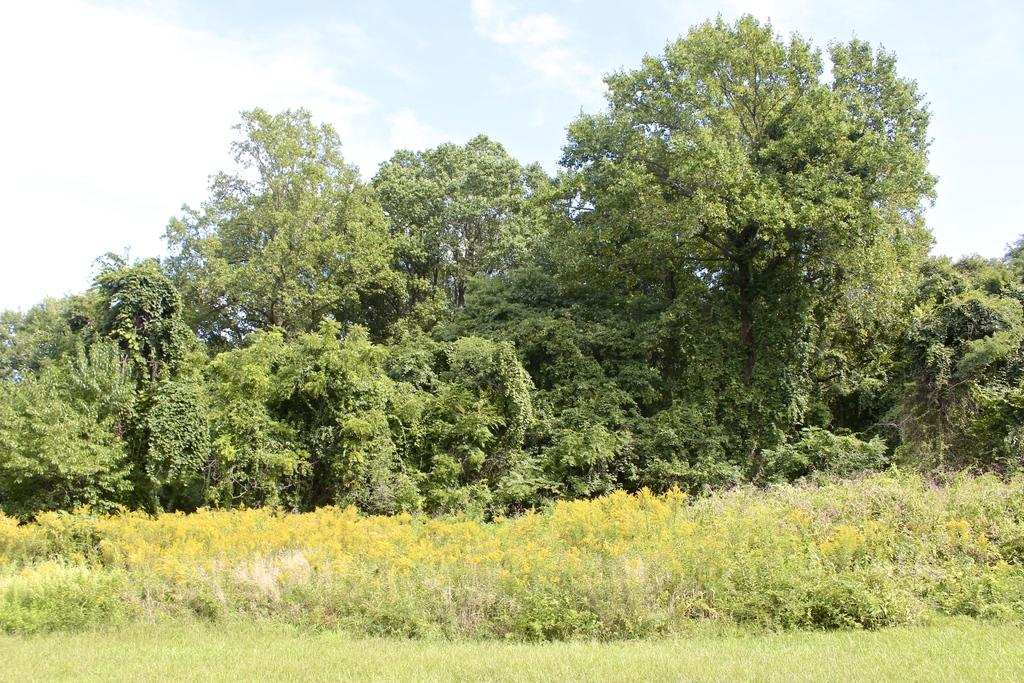What type of vegetation is at the bottom of the image? There is grass at the bottom of the image. What other types of vegetation can be seen in the image? There are small plants and trees visible in the image. What is visible at the top of the image? The sky is visible at the top of the image. Can you see a carriage in the image? No, there is no carriage present in the image. What type of boot is visible on the small plants in the image? There are no boots present in the image; it features grass, small plants, trees, and the sky. 